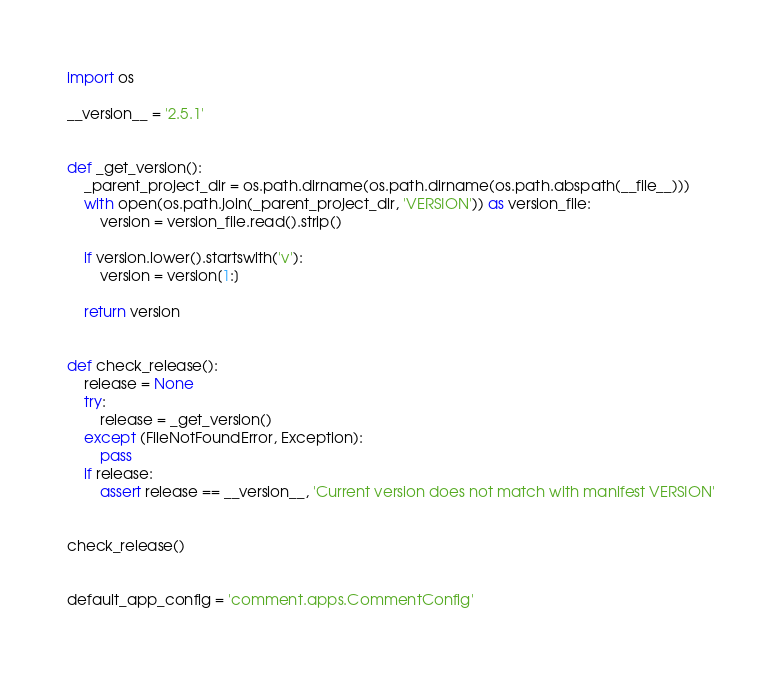<code> <loc_0><loc_0><loc_500><loc_500><_Python_>import os

__version__ = '2.5.1'


def _get_version():
    _parent_project_dir = os.path.dirname(os.path.dirname(os.path.abspath(__file__)))
    with open(os.path.join(_parent_project_dir, 'VERSION')) as version_file:
        version = version_file.read().strip()

    if version.lower().startswith('v'):
        version = version[1:]

    return version


def check_release():
    release = None
    try:
        release = _get_version()
    except (FileNotFoundError, Exception):
        pass
    if release:
        assert release == __version__, 'Current version does not match with manifest VERSION'


check_release()


default_app_config = 'comment.apps.CommentConfig'
</code> 